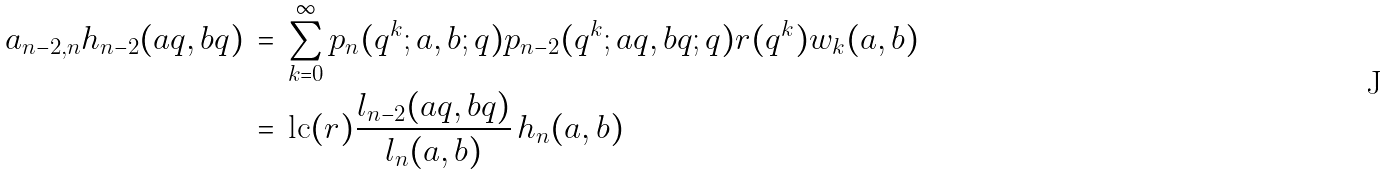<formula> <loc_0><loc_0><loc_500><loc_500>a _ { n - 2 , n } h _ { n - 2 } ( a q , b q ) \, & = \, \sum _ { k = 0 } ^ { \infty } p _ { n } ( q ^ { k } ; a , b ; q ) p _ { n - 2 } ( q ^ { k } ; a q , b q ; q ) r ( q ^ { k } ) w _ { k } ( a , b ) \\ \, & = \, \text {lc} ( r ) \frac { l _ { n - 2 } ( a q , b q ) } { l _ { n } ( a , b ) } \, h _ { n } ( a , b )</formula> 